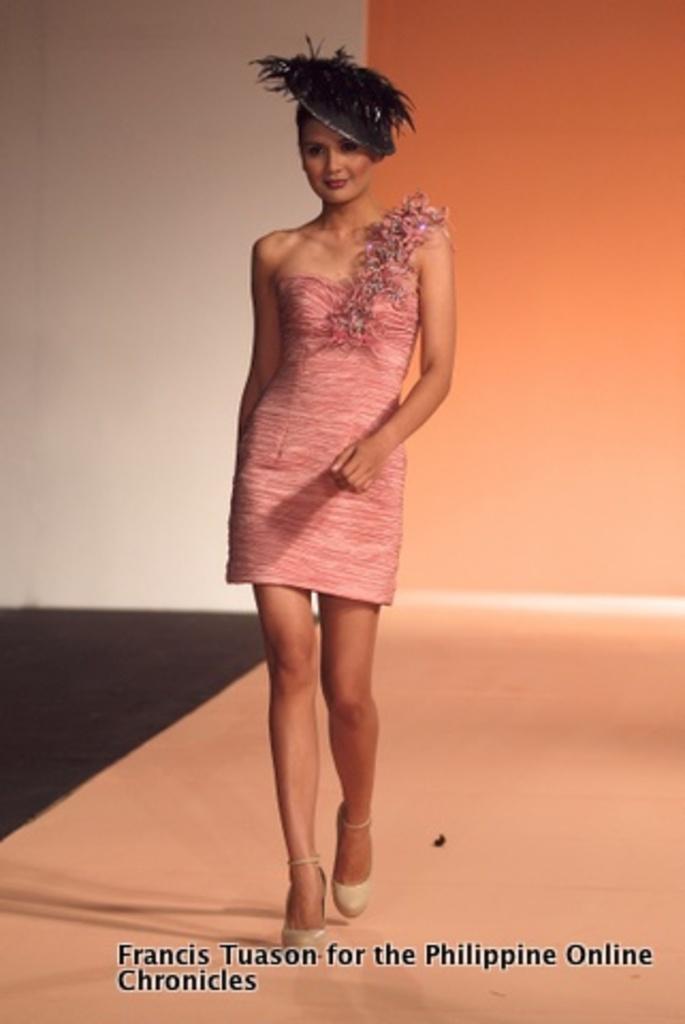Please provide a concise description of this image. In this image, we can see a lady wearing hat and walking on the stage. 